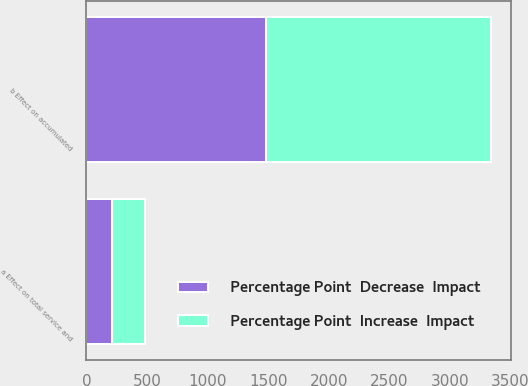<chart> <loc_0><loc_0><loc_500><loc_500><stacked_bar_chart><ecel><fcel>a Effect on total service and<fcel>b Effect on accumulated<nl><fcel>Percentage Point  Increase  Impact<fcel>272<fcel>1857<nl><fcel>Percentage Point  Decrease  Impact<fcel>211<fcel>1483<nl></chart> 